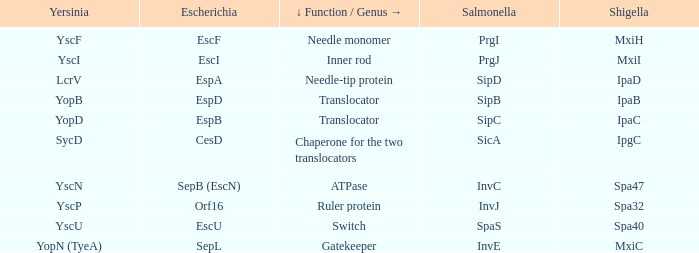Would you mind parsing the complete table? {'header': ['Yersinia', 'Escherichia', '↓ Function / Genus →', 'Salmonella', 'Shigella'], 'rows': [['YscF', 'EscF', 'Needle monomer', 'PrgI', 'MxiH'], ['YscI', 'EscI', 'Inner rod', 'PrgJ', 'MxiI'], ['LcrV', 'EspA', 'Needle-tip protein', 'SipD', 'IpaD'], ['YopB', 'EspD', 'Translocator', 'SipB', 'IpaB'], ['YopD', 'EspB', 'Translocator', 'SipC', 'IpaC'], ['SycD', 'CesD', 'Chaperone for the two translocators', 'SicA', 'IpgC'], ['YscN', 'SepB (EscN)', 'ATPase', 'InvC', 'Spa47'], ['YscP', 'Orf16', 'Ruler protein', 'InvJ', 'Spa32'], ['YscU', 'EscU', 'Switch', 'SpaS', 'Spa40'], ['YopN (TyeA)', 'SepL', 'Gatekeeper', 'InvE', 'MxiC']]} Share the shigella for yersinia yopb. IpaB. 